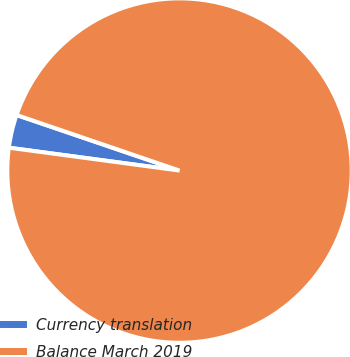<chart> <loc_0><loc_0><loc_500><loc_500><pie_chart><fcel>Currency translation<fcel>Balance March 2019<nl><fcel>3.11%<fcel>96.89%<nl></chart> 